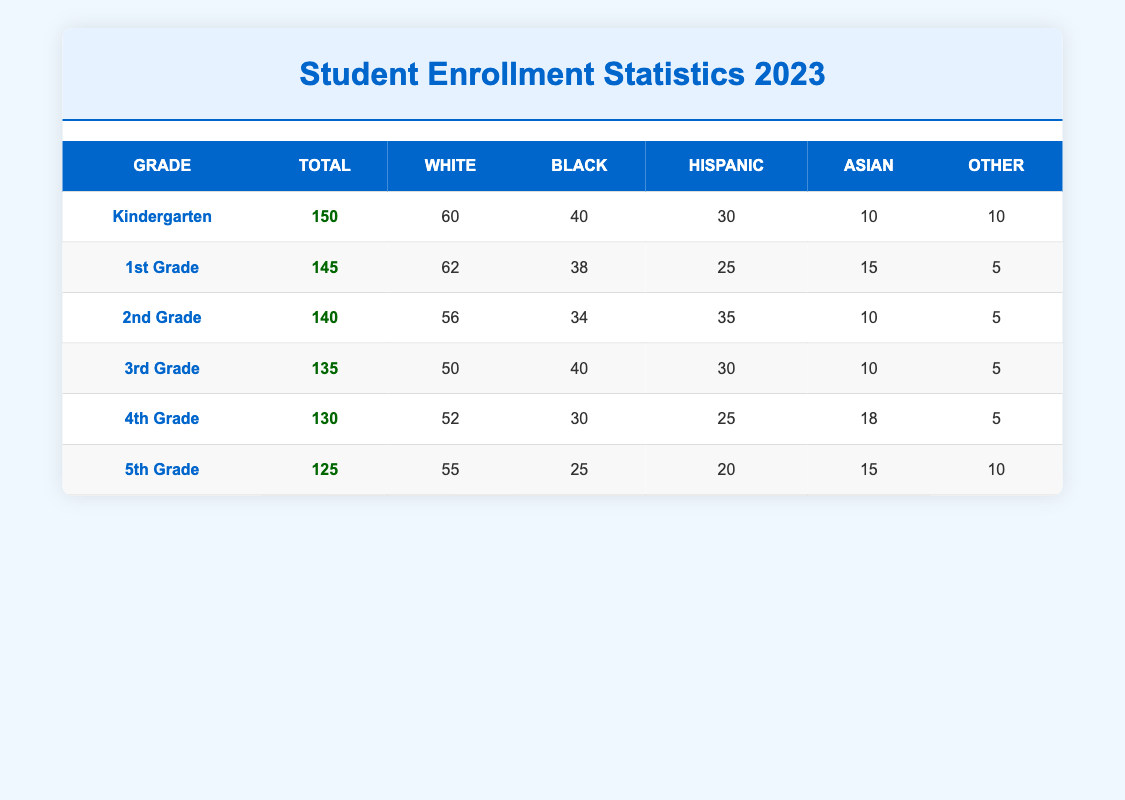What is the total enrollment in 3rd Grade? The table indicates the total enrollment for 3rd Grade is listed directly under the "Total" column for that grade. According to the data, 3rd Grade has a total enrollment of 135 students.
Answer: 135 Which grade has the highest number of Hispanic students? To find the grade with the highest number of Hispanic students, we need to look at the "Hispanic" column across all grades. The values are: Kindergarten (30), 1st Grade (25), 2nd Grade (35), 3rd Grade (30), 4th Grade (25), and 5th Grade (20). The highest value is 35, found in 2nd Grade.
Answer: 2nd Grade What is the percentage of Black students in Kindergarten? The total enrollment in Kindergarten is 150 students, and the number of Black students is 40. To calculate the percentage, use the formula (Number of Black Students / Total Enrollment) * 100. This is (40 / 150) * 100 = 26.67%.
Answer: 26.67% Are there more Asian students in 4th Grade than in 5th Grade? The number of Asian students in 4th Grade is 18, while in 5th Grade it is 15. To compare, we note that 18 is greater than 15. Thus, there are indeed more Asian students in 4th Grade.
Answer: Yes What is the average number of White students across all grades? First, we sum the number of White students across the grades: Kindergarten (60), 1st Grade (62), 2nd Grade (56), 3rd Grade (50), 4th Grade (52), and 5th Grade (55). The total number is 60 + 62 + 56 + 50 + 52 + 55 = 335. There are 6 grades, so we divide by 6 to get the average: 335 / 6 = 55.83.
Answer: 55.83 Which demographic group has the least representation in 1st Grade? In the 1st Grade demographics, the values are: White (62), Black (38), Hispanic (25), Asian (15), Other (5). Out of these, the "Other" category has the lowest count with 5 students.
Answer: Other Is the total number of students in 5th Grade less than the total in 2nd Grade? The total enrollment in 5th Grade is 125, while in 2nd Grade it is 140. Since 125 is less than 140, we can conclude that the total in 5th Grade is indeed less than in 2nd Grade.
Answer: Yes What is the difference in total enrollment between Kindergarten and 4th Grade? The total enrollment in Kindergarten is 150 and in 4th Grade is 130. To find the difference, subtract the total in 4th Grade from Kindergarten: 150 - 130 = 20. This means there are 20 more students in Kindergarten than in 4th Grade.
Answer: 20 What is the total number of non-White students in 2nd Grade? For 2nd Grade, the demographics are as follows: Black (34), Hispanic (35), Asian (10), and Other (5). We sum these values to calculate the total number of non-White students: 34 + 35 + 10 + 5 = 84.
Answer: 84 